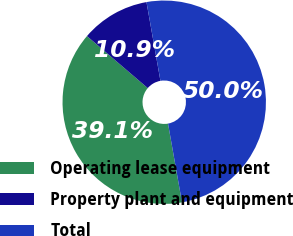Convert chart to OTSL. <chart><loc_0><loc_0><loc_500><loc_500><pie_chart><fcel>Operating lease equipment<fcel>Property plant and equipment<fcel>Total<nl><fcel>39.06%<fcel>10.94%<fcel>50.0%<nl></chart> 